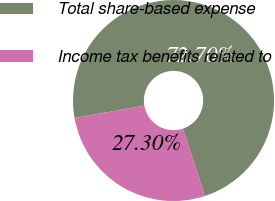Convert chart. <chart><loc_0><loc_0><loc_500><loc_500><pie_chart><fcel>Total share-based expense<fcel>Income tax benefits related to<nl><fcel>72.7%<fcel>27.3%<nl></chart> 